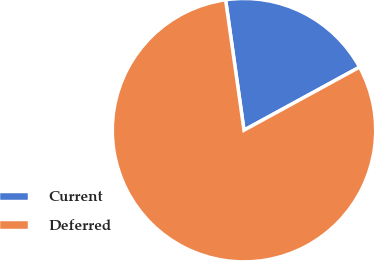Convert chart. <chart><loc_0><loc_0><loc_500><loc_500><pie_chart><fcel>Current<fcel>Deferred<nl><fcel>19.28%<fcel>80.72%<nl></chart> 